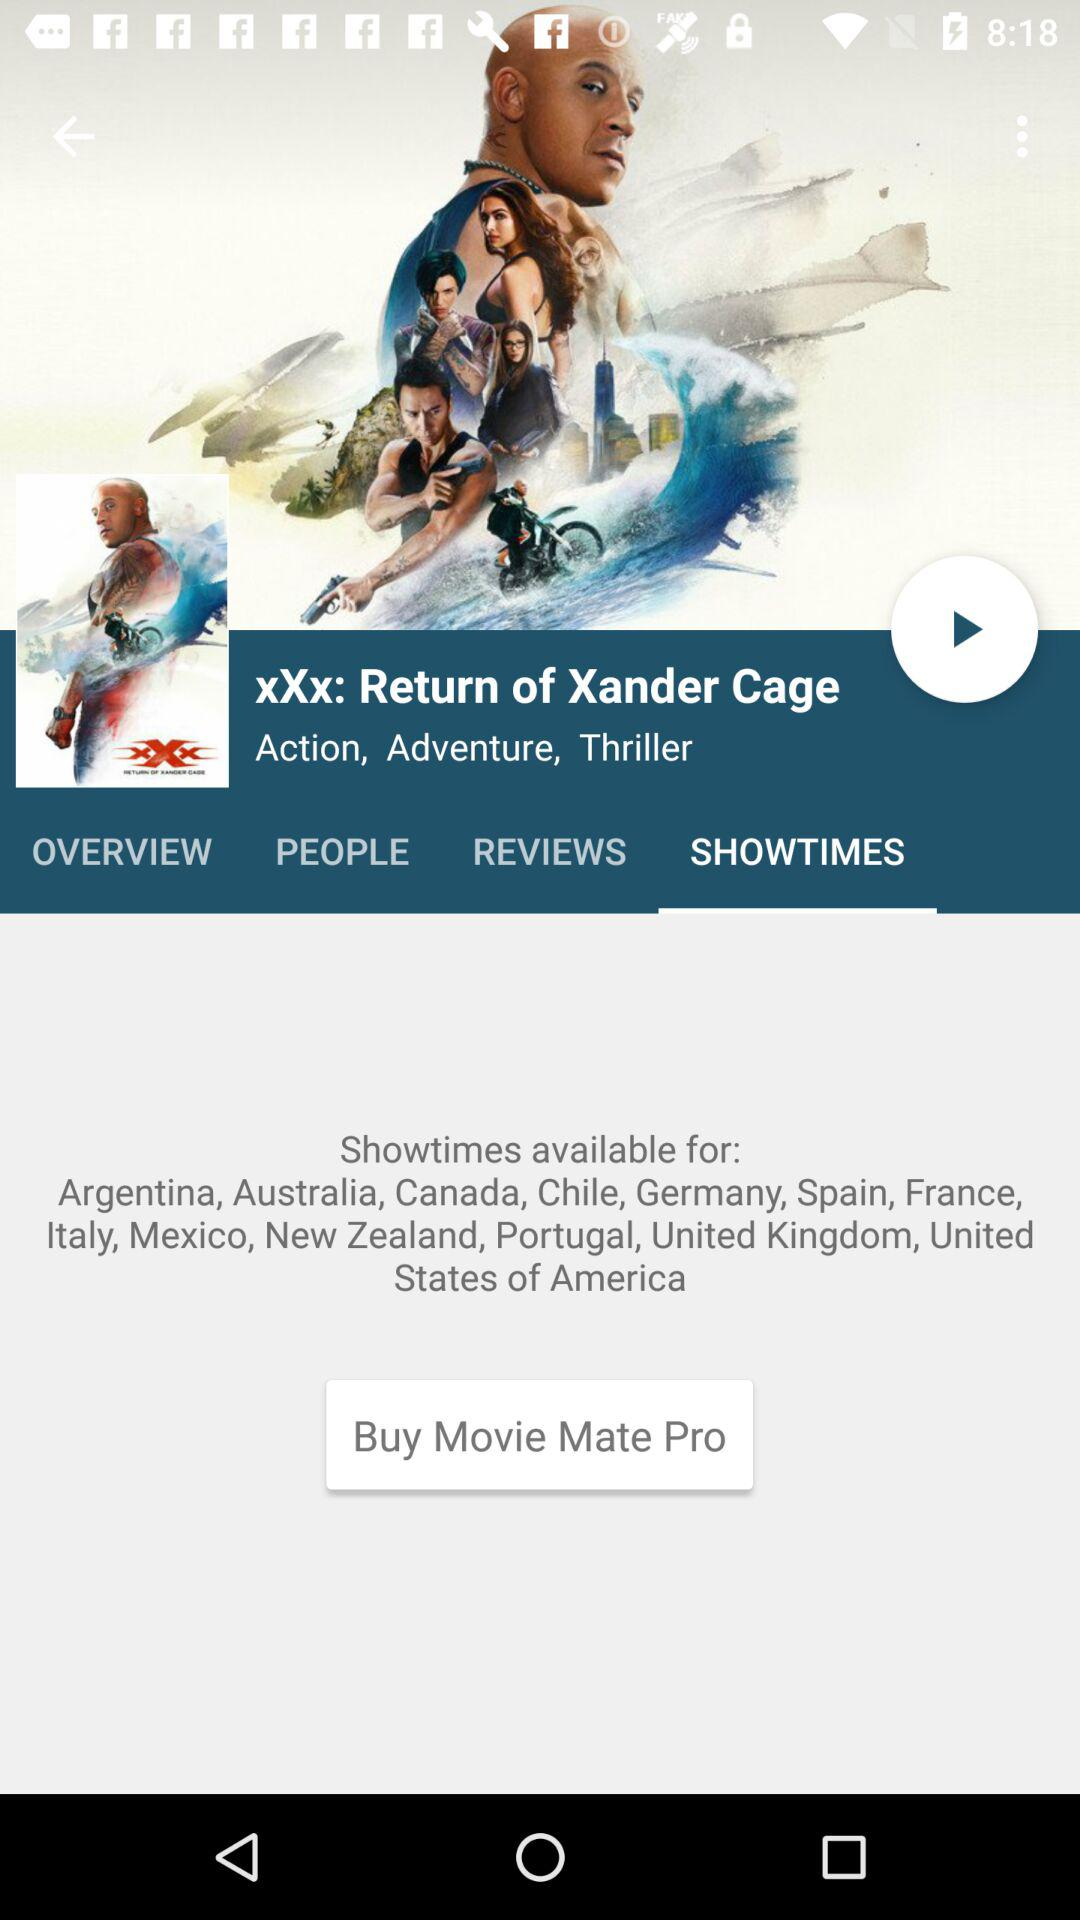What are the movie genres? The movie genres are Action, Adventure and Thriller. 